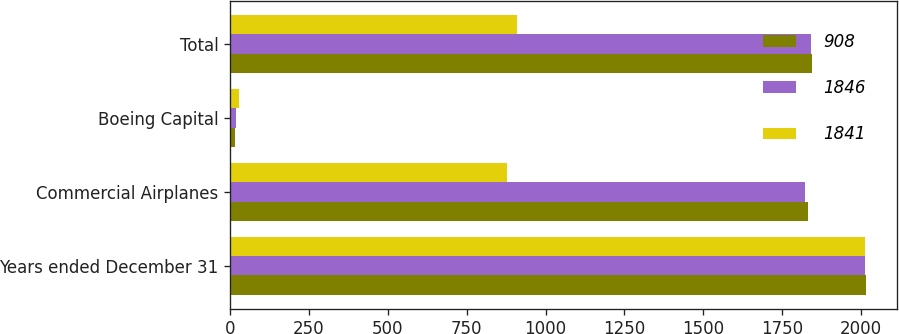Convert chart. <chart><loc_0><loc_0><loc_500><loc_500><stacked_bar_chart><ecel><fcel>Years ended December 31<fcel>Commercial Airplanes<fcel>Boeing Capital<fcel>Total<nl><fcel>908<fcel>2015<fcel>1831<fcel>15<fcel>1846<nl><fcel>1846<fcel>2014<fcel>1822<fcel>19<fcel>1841<nl><fcel>1841<fcel>2013<fcel>879<fcel>29<fcel>908<nl></chart> 